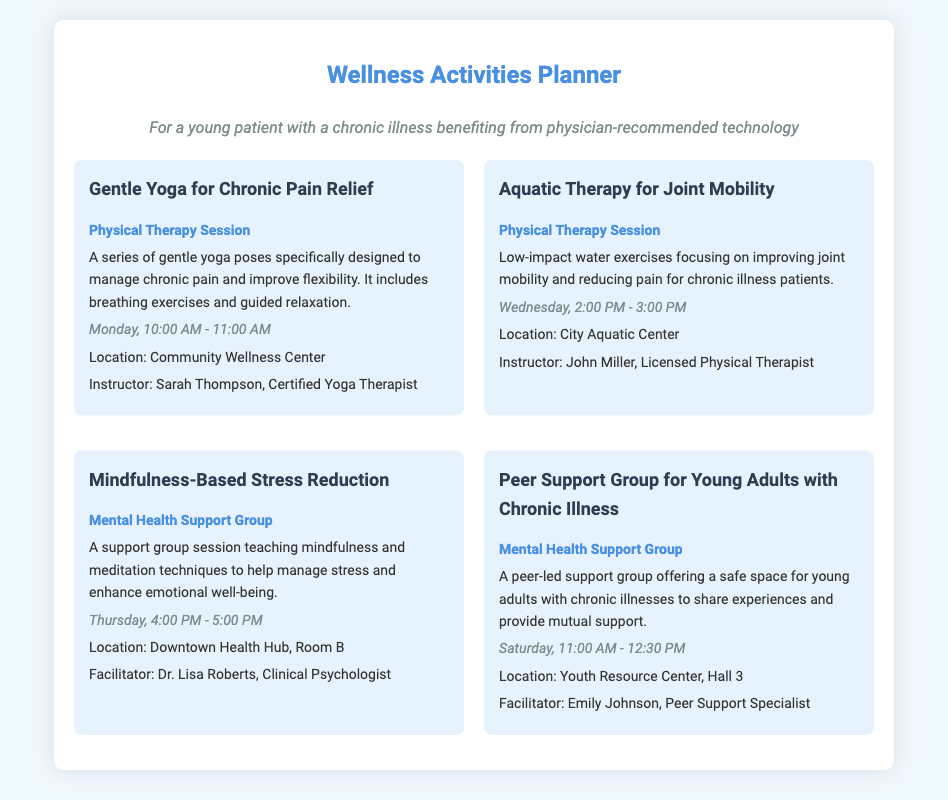What day and time is the Gentle Yoga for Chronic Pain Relief session? The schedule for the Gentle Yoga for Chronic Pain Relief session is Monday from 10:00 AM to 11:00 AM.
Answer: Monday, 10:00 AM - 11:00 AM Who is the instructor for the Aquatic Therapy for Joint Mobility? The instructor for the Aquatic Therapy for Joint Mobility is John Miller, a Licensed Physical Therapist.
Answer: John Miller What is the focus of the Mindfulness-Based Stress Reduction session? The focus of the Mindfulness-Based Stress Reduction session is teaching mindfulness and meditation techniques to help manage stress.
Answer: Mindfulness and meditation techniques When is the Peer Support Group for Young Adults with Chronic Illness held? The Peer Support Group for Young Adults with Chronic Illness is held on Saturday at 11:00 AM.
Answer: Saturday, 11:00 AM What is the location for the Mindfulness-Based Stress Reduction session? The location for the Mindfulness-Based Stress Reduction session is Downtown Health Hub, Room B.
Answer: Downtown Health Hub, Room B How long does the Peer Support Group session last? The Peer Support Group session lasts for 1 hour and 30 minutes.
Answer: 1 hour and 30 minutes Which activity focuses on enhancing emotional well-being? The Mindfulness-Based Stress Reduction session focuses on enhancing emotional well-being.
Answer: Mindfulness-Based Stress Reduction What type of activity is Aquatic Therapy for Joint Mobility classified as? Aquatic Therapy for Joint Mobility is classified as a Physical Therapy Session.
Answer: Physical Therapy Session 